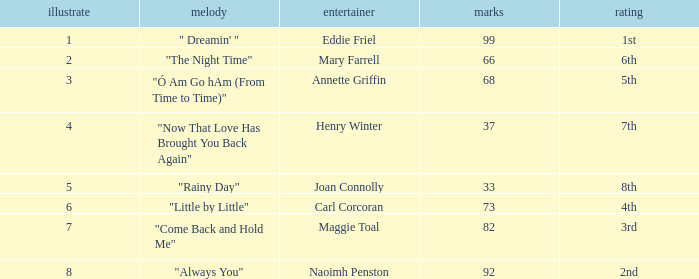What is the lowest points when the ranking is 1st? 99.0. I'm looking to parse the entire table for insights. Could you assist me with that? {'header': ['illustrate', 'melody', 'entertainer', 'marks', 'rating'], 'rows': [['1', '" Dreamin\' "', 'Eddie Friel', '99', '1st'], ['2', '"The Night Time"', 'Mary Farrell', '66', '6th'], ['3', '"Ó Am Go hAm (From Time to Time)"', 'Annette Griffin', '68', '5th'], ['4', '"Now That Love Has Brought You Back Again"', 'Henry Winter', '37', '7th'], ['5', '"Rainy Day"', 'Joan Connolly', '33', '8th'], ['6', '"Little by Little"', 'Carl Corcoran', '73', '4th'], ['7', '"Come Back and Hold Me"', 'Maggie Toal', '82', '3rd'], ['8', '"Always You"', 'Naoimh Penston', '92', '2nd']]} 